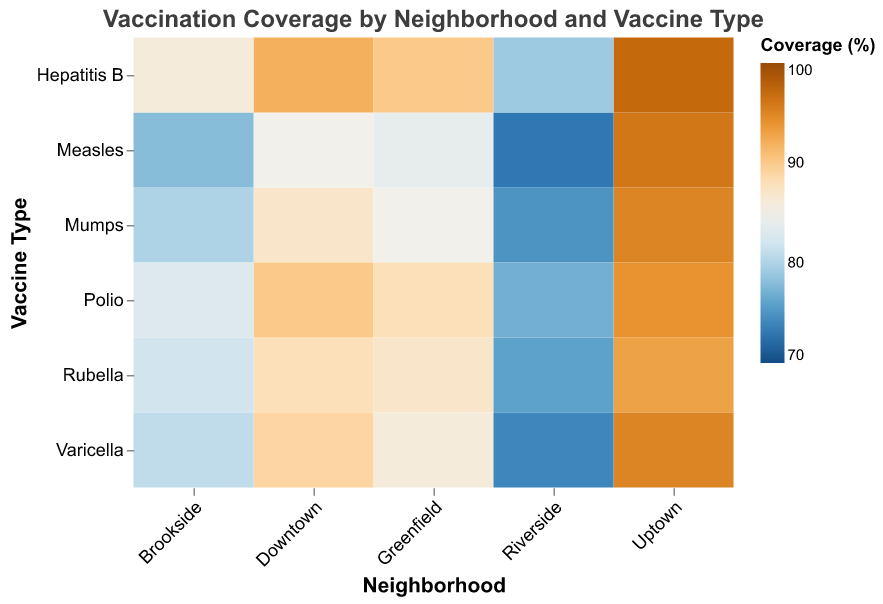What is the title of the heatmap? The title of the heatmap is positioned at the top center and it reads "Vaccination Coverage by Neighborhood and Vaccine Type."
Answer: Vaccination Coverage by Neighborhood and Vaccine Type Which neighborhood has the highest vaccination coverage for Measles? By looking at the color shades corresponding to Measles across neighborhoods, Uptown has the highest vaccination coverage indicated by the darkest color for Measles.
Answer: Uptown What is the range of vaccination coverage percentages depicted in the heatmap? The legend on the right side of the heatmap indicates the range of coverage percentages from 70% to 100%.
Answer: 70% to 100% Which vaccine has the lowest coverage in Riverside? By examining the lightest color associated with Riverside across different vaccines within the heatmap, Measles has the lowest coverage at 73%.
Answer: Measles Compare the vaccination coverage for Polio between Downtown and Riverside. Riverside has a lower coverage for Polio at 77%, while Downtown has a higher coverage at 90%. This is observed by comparing the color shades corresponding to Polio for both neighborhoods.
Answer: Downtown: 90%, Riverside: 77% Which neighborhood has the most uniform vaccination coverage across all vaccines? By comparing color uniformity across all vaccines per neighborhood, Uptown shows the most uniform coverage characterized by consistently dark shades across all vaccine types.
Answer: Uptown Calculate the average vaccination coverage for Varicella across all neighborhoods. Adding the percentages for Varicella for each neighborhood and dividing by the number of neighborhoods: (89 + 81 + 95 + 86 + 74) / 5 = 85%.
Answer: 85% Which vaccine has the highest average coverage across all neighborhoods? Calculating the average for each vaccine and comparing: Mumps (87.4), Measles (83.2), Rubella (85.2), Polio (86.4), Hepatitis B (88.8), Varicella (85). Hepatitis B has the highest average at 88.8%.
Answer: Hepatitis B In which neighborhood is the coverage for Hepatitis B closest to 90%? By checking the shading and exact percentage values for Hepatitis B across neighborhoods, Greenfield has a coverage value of 90%, which is closest to 90%.
Answer: Greenfield 